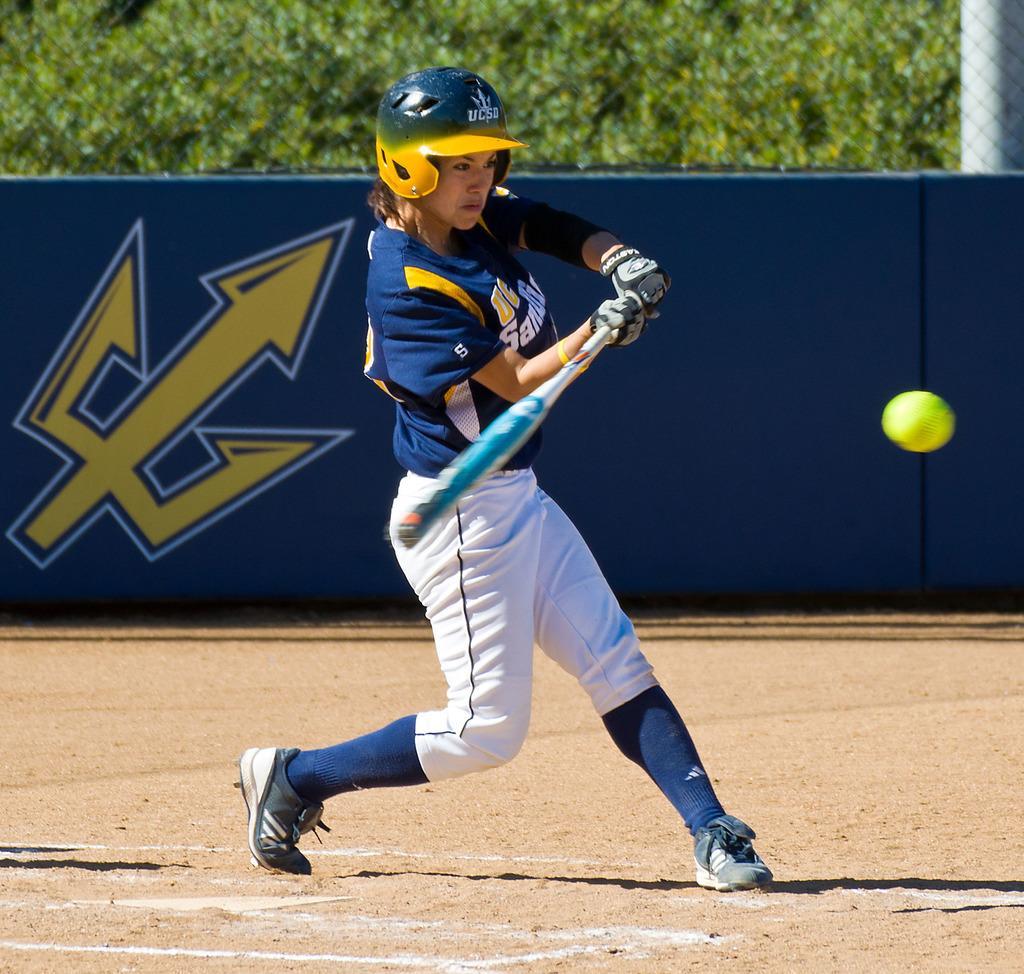How would you summarize this image in a sentence or two? In this image in the center there is a woman playing, holding a bat in her hand. In the background there are trees, there is fence and there is a banner which is blue in colour and there is a symbol on the banner. In the front on the right side there is a ball in the air. 